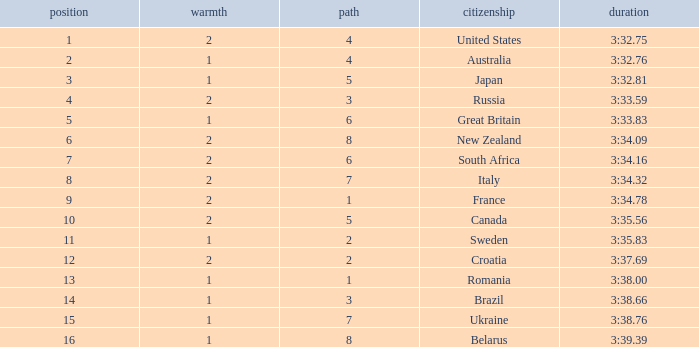Can you tell me the Rank that has the Lane of 6, and the Heat of 2? 7.0. 